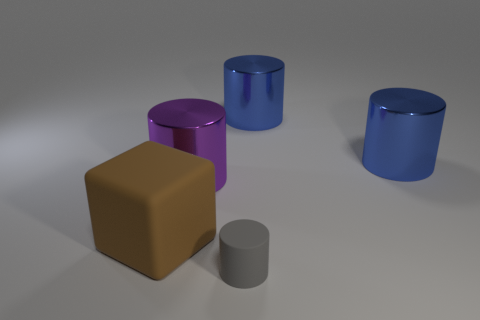Are the object that is to the left of the purple thing and the object that is in front of the large cube made of the same material?
Provide a succinct answer. Yes. What number of gray things are there?
Ensure brevity in your answer.  1. What number of gray rubber things have the same shape as the large purple metal object?
Your answer should be very brief. 1. Is the tiny gray thing the same shape as the big purple metallic thing?
Your response must be concise. Yes. What size is the purple shiny cylinder?
Your answer should be compact. Large. What number of cylinders have the same size as the rubber cube?
Make the answer very short. 3. Is the size of the rubber object to the right of the big purple metal cylinder the same as the matte thing that is on the left side of the large purple cylinder?
Offer a terse response. No. There is a matte object that is left of the tiny rubber cylinder; what is its shape?
Give a very brief answer. Cube. What is the material of the large cylinder that is on the left side of the rubber thing in front of the rubber cube?
Your response must be concise. Metal. Do the purple metal object and the cylinder in front of the big purple thing have the same size?
Keep it short and to the point. No. 